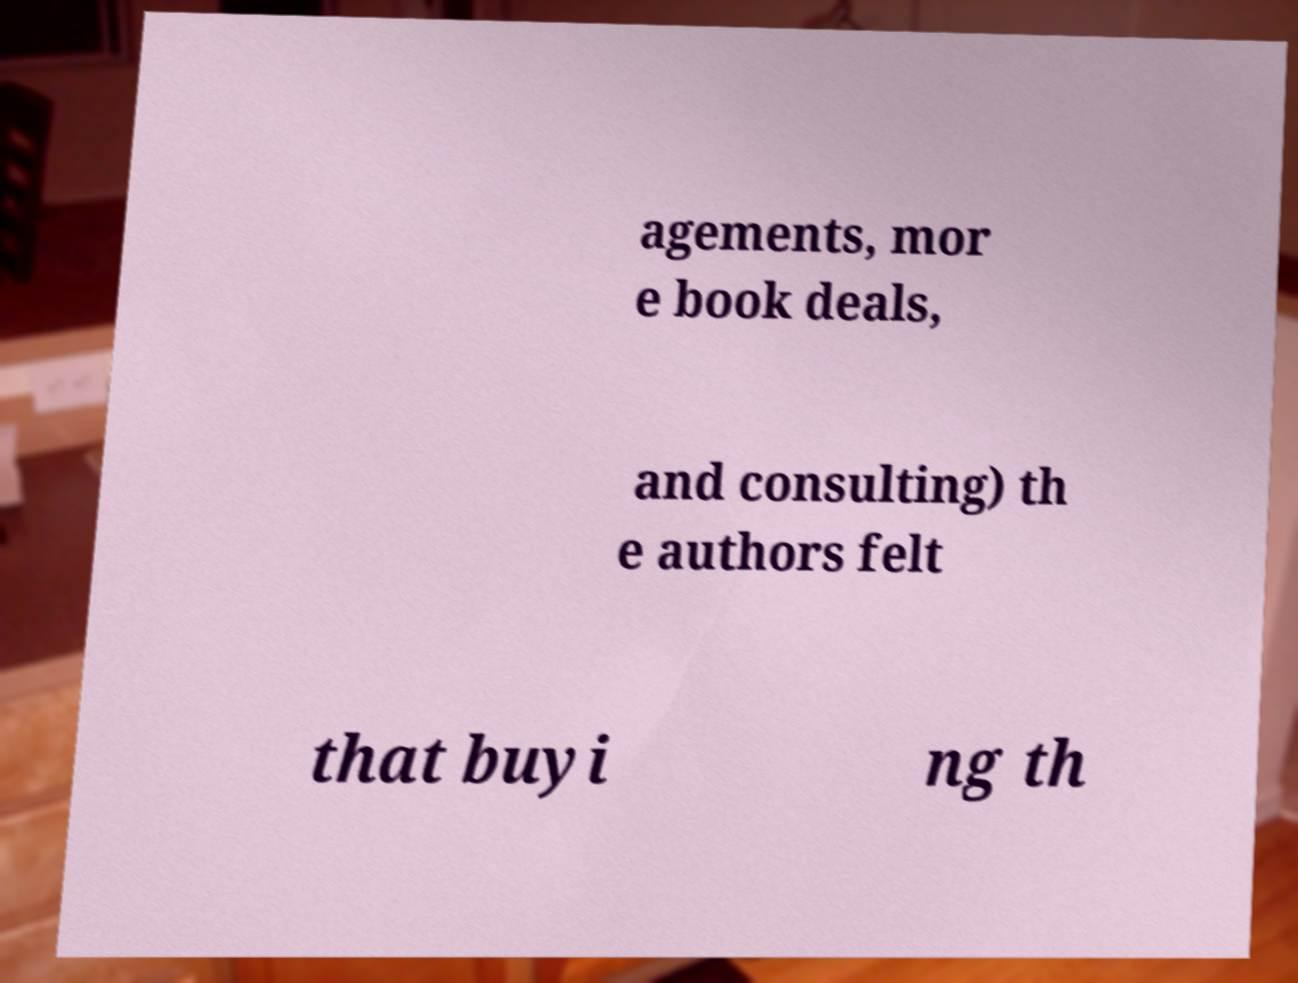Could you assist in decoding the text presented in this image and type it out clearly? agements, mor e book deals, and consulting) th e authors felt that buyi ng th 